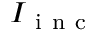Convert formula to latex. <formula><loc_0><loc_0><loc_500><loc_500>I _ { i n c }</formula> 